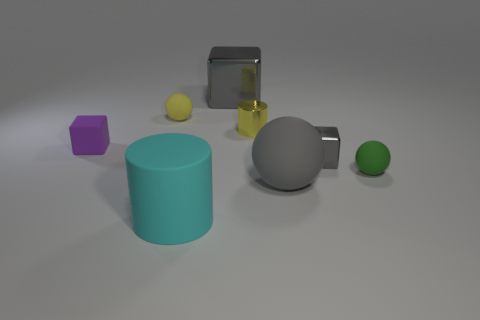What number of cubes are both behind the small gray shiny block and right of the big cyan cylinder?
Ensure brevity in your answer.  1. What is the material of the small ball that is left of the tiny ball on the right side of the big gray block?
Provide a succinct answer. Rubber. There is a large object that is the same shape as the tiny gray object; what is it made of?
Provide a succinct answer. Metal. Are there any brown rubber cubes?
Keep it short and to the point. No. There is a tiny thing that is made of the same material as the tiny yellow cylinder; what is its shape?
Ensure brevity in your answer.  Cube. What is the material of the small block to the left of the small cylinder?
Your answer should be compact. Rubber. Does the big thing behind the gray ball have the same color as the large sphere?
Give a very brief answer. Yes. How big is the matte block in front of the cylinder on the right side of the big cylinder?
Make the answer very short. Small. Is the number of objects that are to the left of the big cyan rubber cylinder greater than the number of large cyan metal objects?
Provide a succinct answer. Yes. There is a rubber ball that is behind the matte cube; does it have the same size as the big cyan object?
Offer a very short reply. No. 